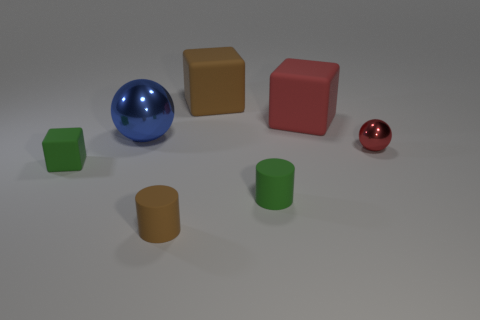Are there more green objects behind the small metallic ball than big brown objects?
Keep it short and to the point. No. The small red shiny object has what shape?
Offer a terse response. Sphere. Does the sphere that is behind the small red metal sphere have the same color as the big matte object right of the brown block?
Provide a succinct answer. No. Does the large blue thing have the same shape as the large brown object?
Keep it short and to the point. No. Are there any other things that are the same shape as the small brown object?
Your answer should be very brief. Yes. Is the brown object that is behind the large red matte thing made of the same material as the small brown cylinder?
Ensure brevity in your answer.  Yes. What is the shape of the matte thing that is on the left side of the big brown cube and behind the brown cylinder?
Offer a very short reply. Cube. There is a big matte thing that is behind the big red matte block; is there a small brown rubber thing behind it?
Give a very brief answer. No. What number of other things are there of the same material as the green cube
Ensure brevity in your answer.  4. Does the tiny green thing right of the big blue sphere have the same shape as the brown thing that is in front of the tiny red metallic sphere?
Give a very brief answer. Yes. 